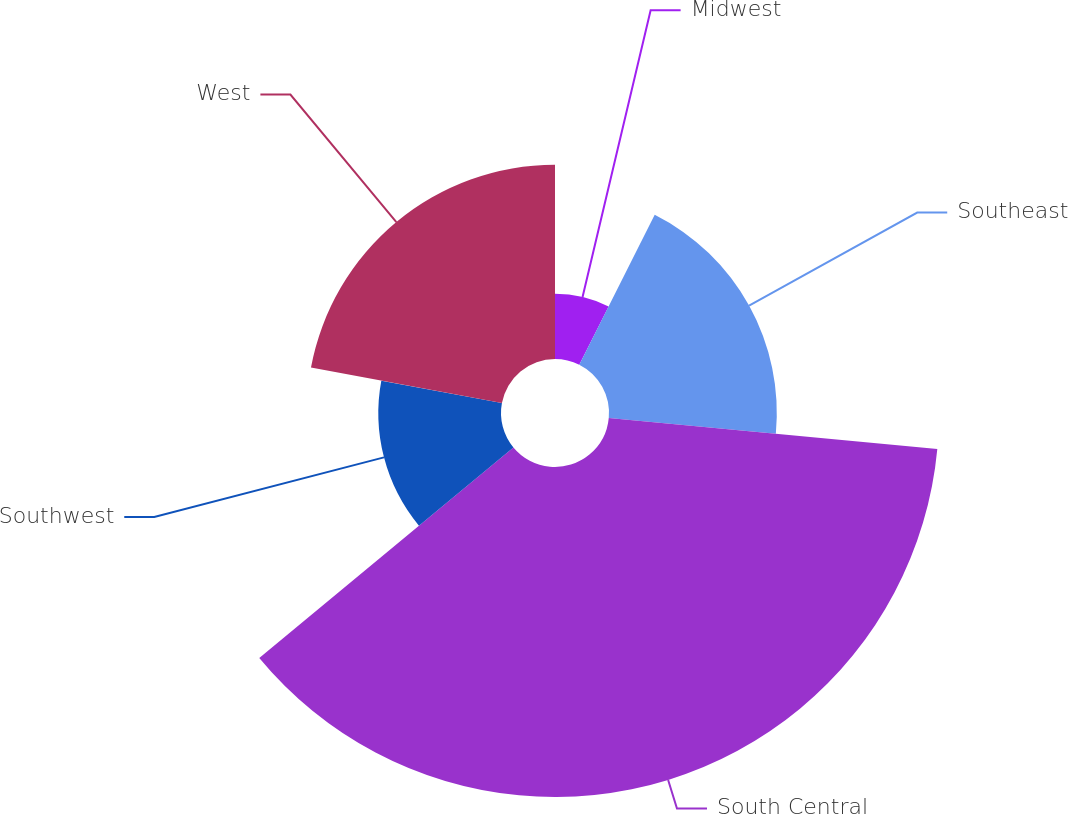<chart> <loc_0><loc_0><loc_500><loc_500><pie_chart><fcel>Midwest<fcel>Southeast<fcel>South Central<fcel>Southwest<fcel>West<nl><fcel>7.42%<fcel>19.07%<fcel>37.5%<fcel>13.94%<fcel>22.07%<nl></chart> 